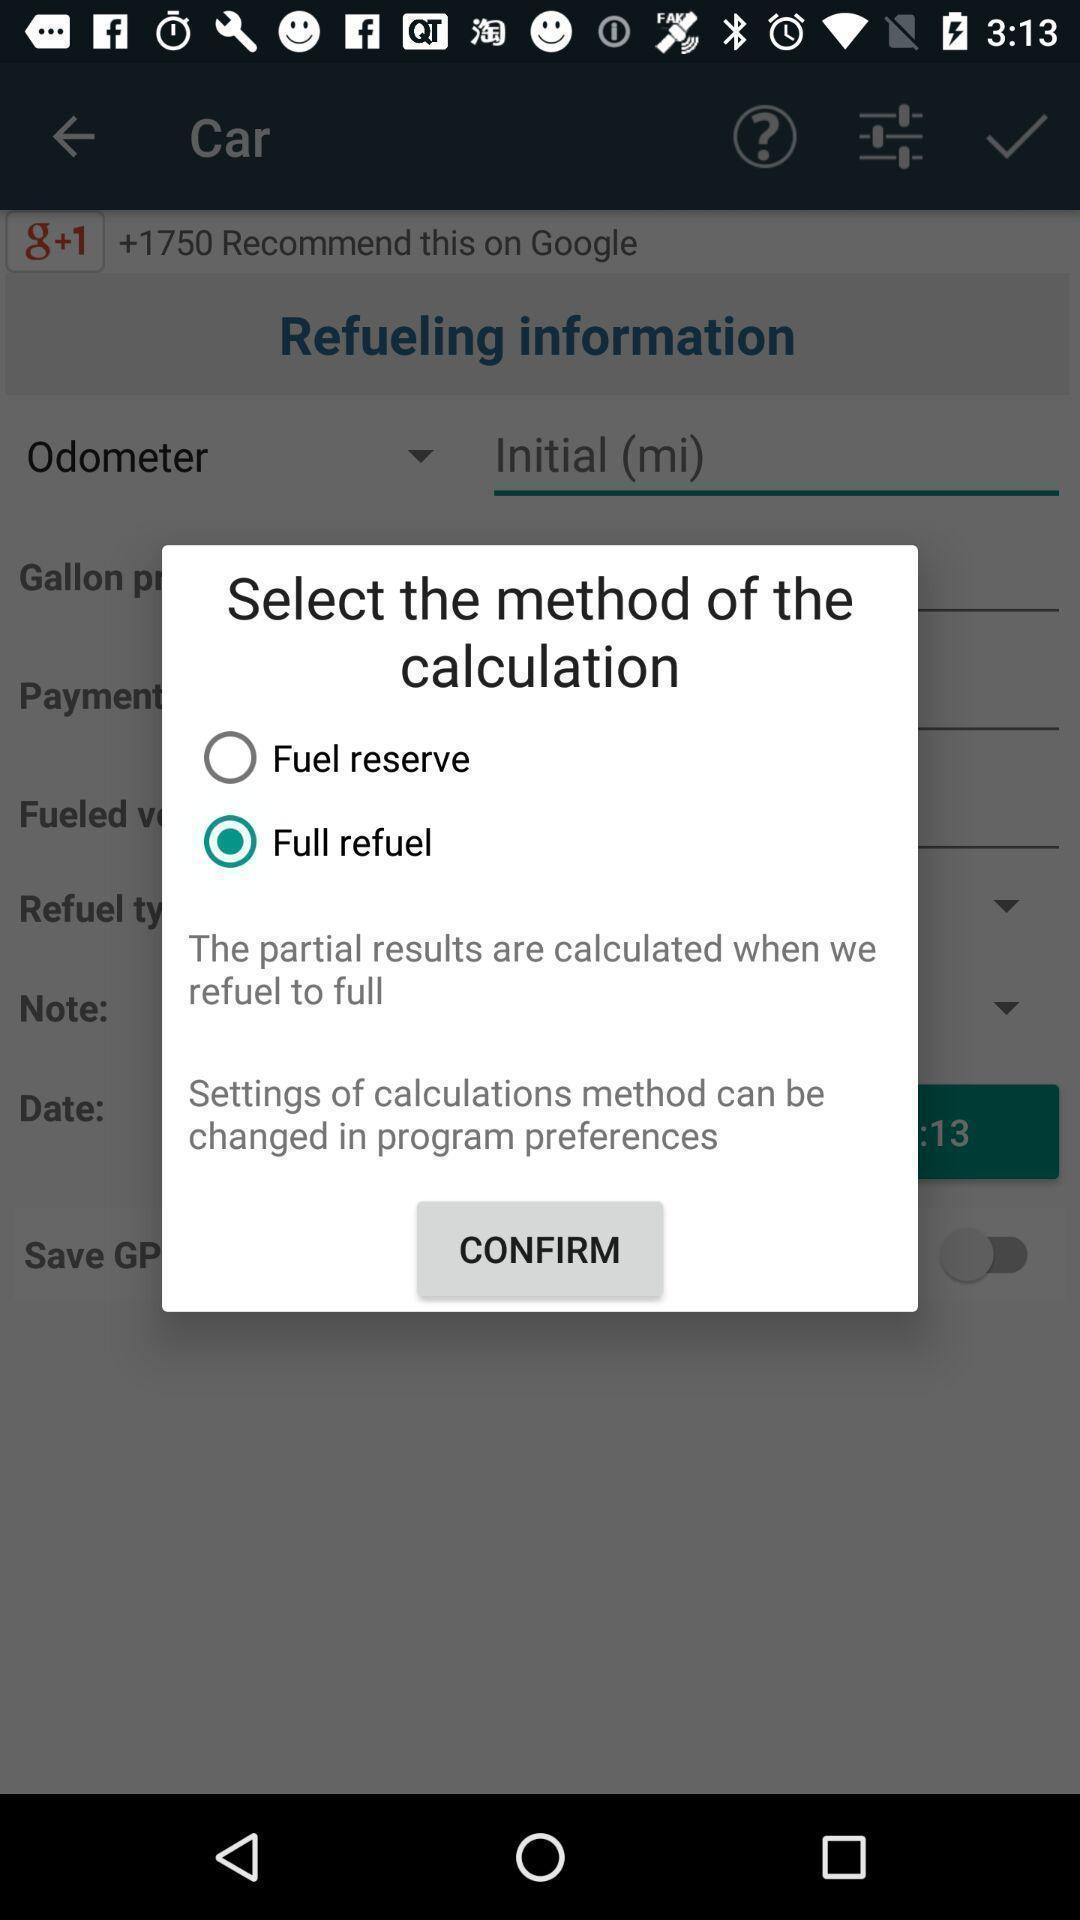Please provide a description for this image. Pop-up shows two selective options in an service application. 